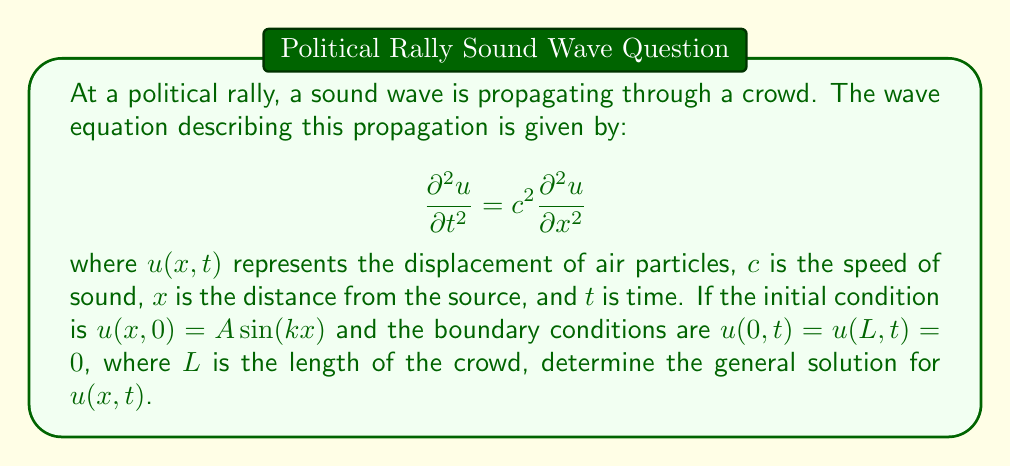What is the answer to this math problem? To solve this wave equation with the given initial and boundary conditions, we'll follow these steps:

1) First, we assume a solution of the form:
   $$u(x,t) = X(x)T(t)$$

2) Substituting this into the wave equation:
   $$X(x)T''(t) = c^2 X''(x)T(t)$$

3) Separating variables:
   $$\frac{T''(t)}{c^2T(t)} = \frac{X''(x)}{X(x)} = -\lambda$$

   where $\lambda$ is a separation constant.

4) This gives us two ordinary differential equations:
   $$T''(t) + \lambda c^2 T(t) = 0$$
   $$X''(x) + \lambda X(x) = 0$$

5) The boundary conditions $u(0,t) = u(L,t) = 0$ imply $X(0) = X(L) = 0$. This gives us the eigenvalue problem:
   $$X(x) = A\sin(\sqrt{\lambda}x)$$
   $$\lambda_n = (\frac{n\pi}{L})^2, n = 1,2,3,...$$

6) For $T(t)$, we have:
   $$T(t) = B\cos(\omega_n t) + C\sin(\omega_n t)$$
   where $\omega_n = c\sqrt{\lambda_n} = \frac{cn\pi}{L}$

7) The general solution is then:
   $$u(x,t) = \sum_{n=1}^{\infty} (B_n\cos(\omega_n t) + C_n\sin(\omega_n t))\sin(\frac{n\pi x}{L})$$

8) To satisfy the initial condition $u(x,0) = A\sin(kx)$, we need:
   $$\sum_{n=1}^{\infty} B_n\sin(\frac{n\pi x}{L}) = A\sin(kx)$$

   This implies $B_n = 0$ for all $n$ except when $\frac{n\pi}{L} = k$, in which case $B_n = A$.

9) Therefore, the final solution is:
   $$u(x,t) = A\cos(\frac{ckn\pi t}{L})\sin(kx)$$
   where $k = \frac{n\pi}{L}$ for some integer $n$.
Answer: $u(x,t) = A\cos(\frac{ckn\pi t}{L})\sin(kx)$, where $k = \frac{n\pi}{L}$ for some integer $n$. 